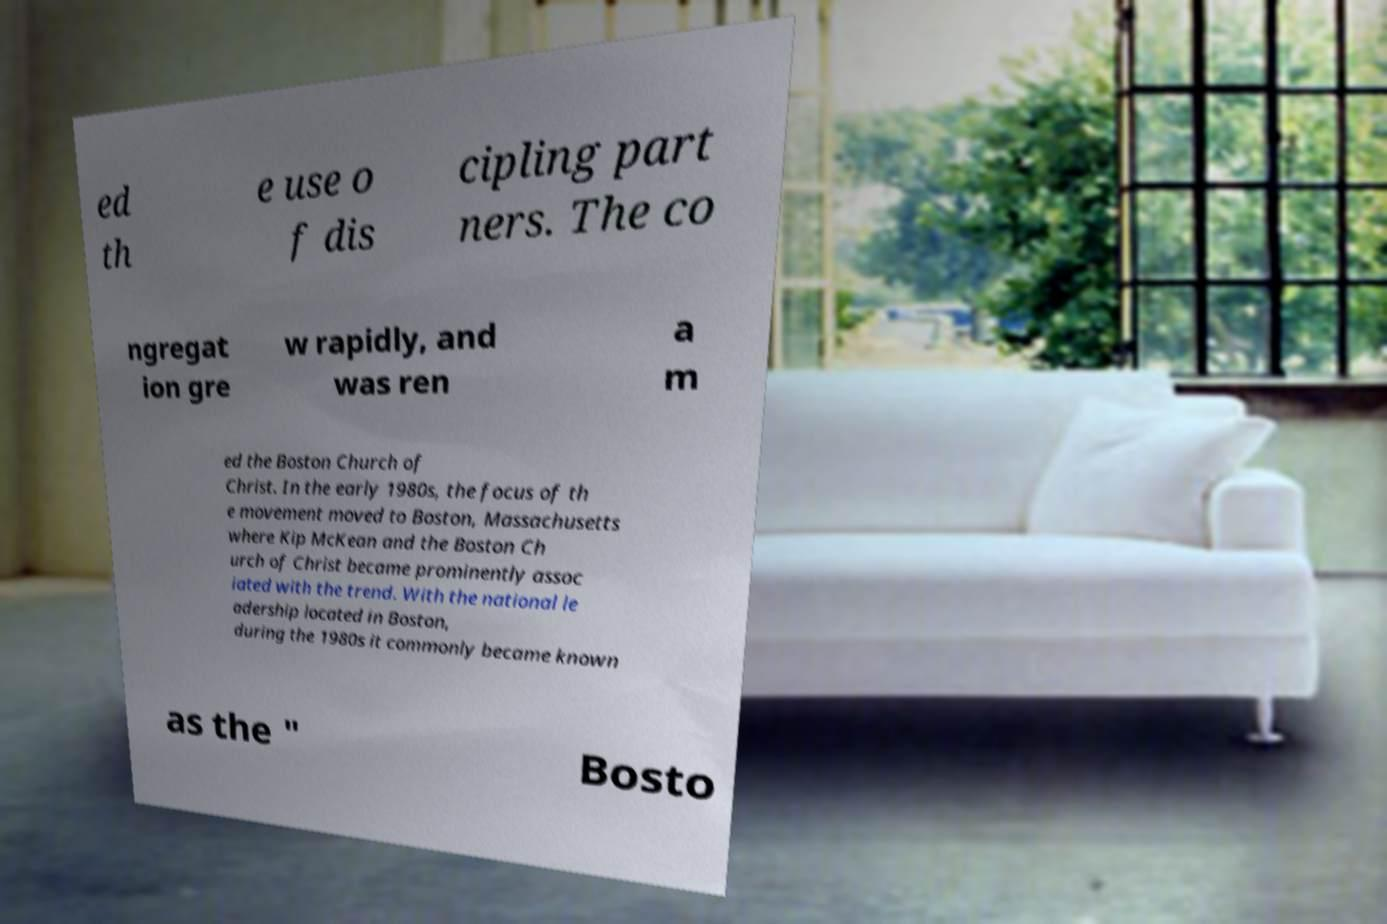There's text embedded in this image that I need extracted. Can you transcribe it verbatim? ed th e use o f dis cipling part ners. The co ngregat ion gre w rapidly, and was ren a m ed the Boston Church of Christ. In the early 1980s, the focus of th e movement moved to Boston, Massachusetts where Kip McKean and the Boston Ch urch of Christ became prominently assoc iated with the trend. With the national le adership located in Boston, during the 1980s it commonly became known as the " Bosto 